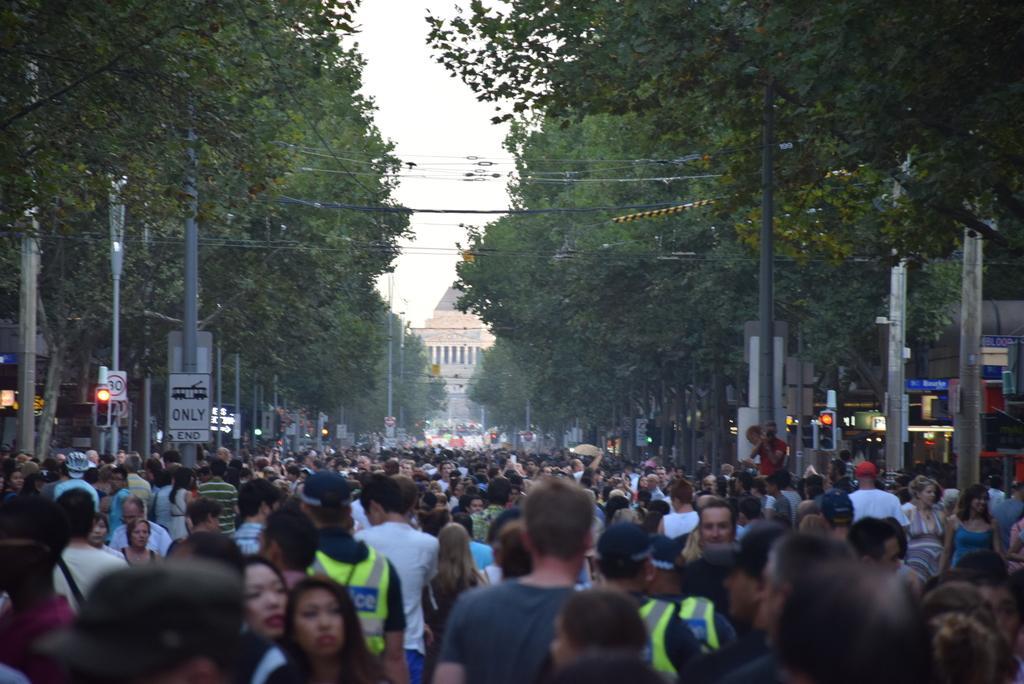Please provide a concise description of this image. In the picture we can see a public on the road and on the either sides of the road we can see some poles and boards to it and some signal lights and we can also see trees and in the background we can see a building with pillars and sky. 